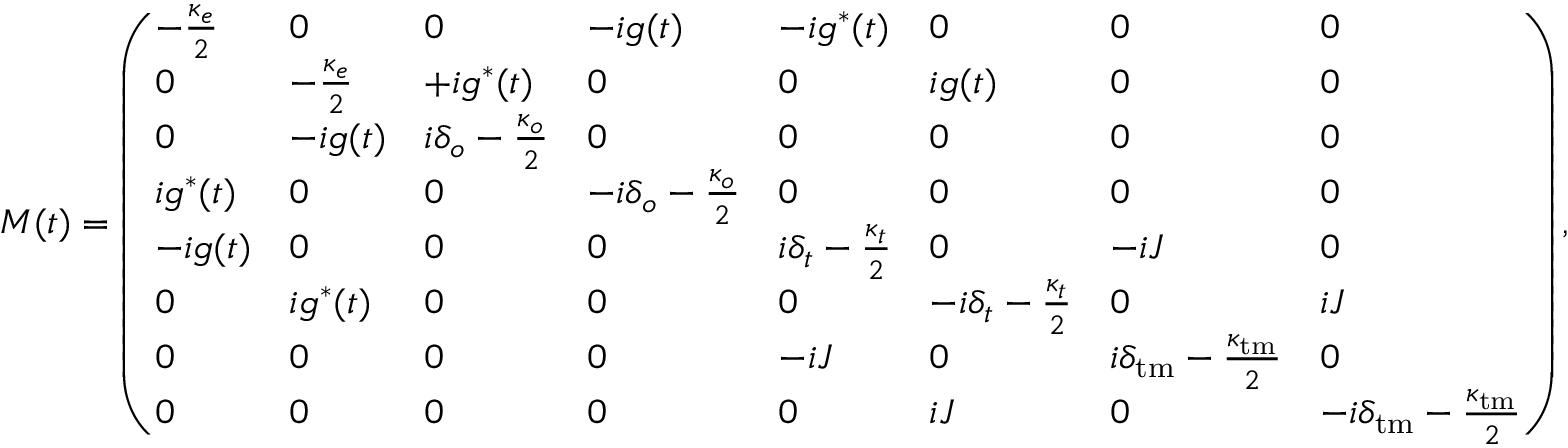<formula> <loc_0><loc_0><loc_500><loc_500>M ( t ) = \left ( \begin{array} { l l l l l l l l } { - \frac { \kappa _ { e } } { 2 } } & { 0 } & { 0 } & { - i g ( t ) } & { - i g ^ { * } ( t ) } & { 0 } & { 0 } & { 0 } \\ { 0 } & { - \frac { \kappa _ { e } } { 2 } } & { + i g ^ { * } ( t ) } & { 0 } & { 0 } & { i g ( t ) } & { 0 } & { 0 } \\ { 0 } & { - i g ( t ) } & { i \delta _ { o } - \frac { \kappa _ { o } } { 2 } } & { 0 } & { 0 } & { 0 } & { 0 } & { 0 } \\ { i g ^ { * } ( t ) } & { 0 } & { 0 } & { - i \delta _ { o } - \frac { \kappa _ { o } } { 2 } } & { 0 } & { 0 } & { 0 } & { 0 } \\ { - i g ( t ) } & { 0 } & { 0 } & { 0 } & { i \delta _ { t } - \frac { \kappa _ { t } } { 2 } } & { 0 } & { - i J } & { 0 } \\ { 0 } & { i g ^ { * } ( t ) } & { 0 } & { 0 } & { 0 } & { - i \delta _ { t } - \frac { \kappa _ { t } } { 2 } } & { 0 } & { i J } \\ { 0 } & { 0 } & { 0 } & { 0 } & { - i J } & { 0 } & { i \delta _ { t m } - \frac { \kappa _ { t m } } { 2 } } & { 0 } \\ { 0 } & { 0 } & { 0 } & { 0 } & { 0 } & { i J } & { 0 } & { - i \delta _ { t m } - \frac { \kappa _ { t m } } { 2 } } \end{array} \right ) ,</formula> 